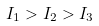<formula> <loc_0><loc_0><loc_500><loc_500>I _ { 1 } > I _ { 2 } > I _ { 3 }</formula> 